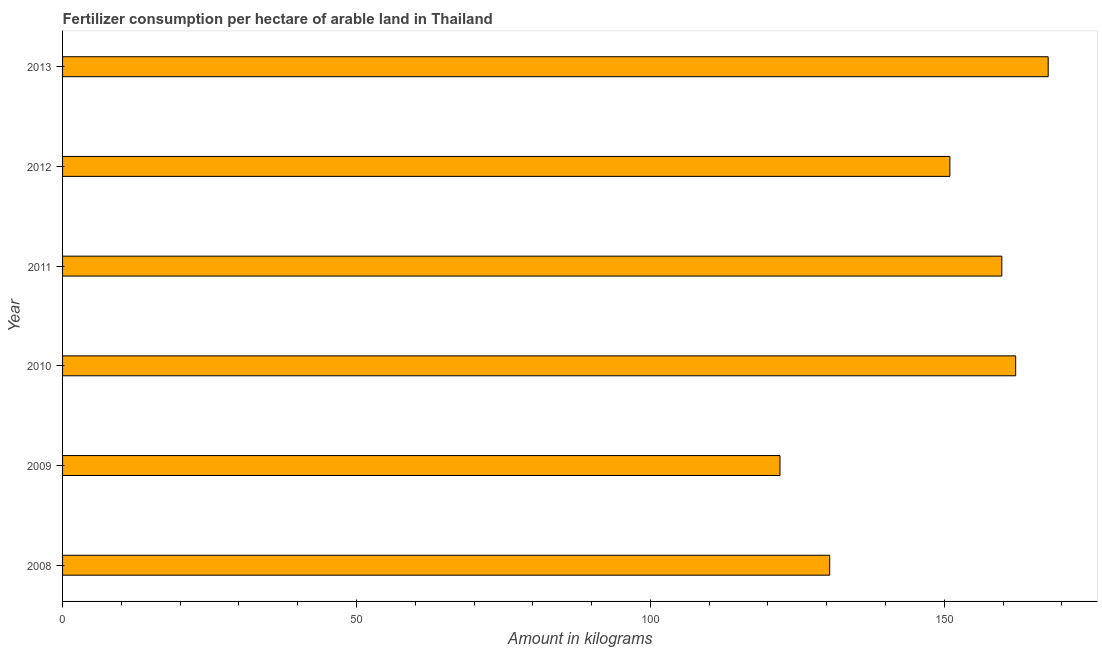Does the graph contain grids?
Provide a short and direct response. No. What is the title of the graph?
Provide a short and direct response. Fertilizer consumption per hectare of arable land in Thailand . What is the label or title of the X-axis?
Your answer should be very brief. Amount in kilograms. What is the amount of fertilizer consumption in 2011?
Give a very brief answer. 159.8. Across all years, what is the maximum amount of fertilizer consumption?
Ensure brevity in your answer.  167.69. Across all years, what is the minimum amount of fertilizer consumption?
Your answer should be very brief. 122.06. In which year was the amount of fertilizer consumption minimum?
Provide a short and direct response. 2009. What is the sum of the amount of fertilizer consumption?
Provide a short and direct response. 893.19. What is the difference between the amount of fertilizer consumption in 2009 and 2010?
Offer a very short reply. -40.1. What is the average amount of fertilizer consumption per year?
Provide a short and direct response. 148.86. What is the median amount of fertilizer consumption?
Ensure brevity in your answer.  155.38. In how many years, is the amount of fertilizer consumption greater than 80 kg?
Make the answer very short. 6. What is the ratio of the amount of fertilizer consumption in 2009 to that in 2010?
Offer a very short reply. 0.75. Is the difference between the amount of fertilizer consumption in 2011 and 2013 greater than the difference between any two years?
Offer a terse response. No. What is the difference between the highest and the second highest amount of fertilizer consumption?
Offer a very short reply. 5.54. Is the sum of the amount of fertilizer consumption in 2010 and 2011 greater than the maximum amount of fertilizer consumption across all years?
Offer a terse response. Yes. What is the difference between the highest and the lowest amount of fertilizer consumption?
Provide a succinct answer. 45.63. In how many years, is the amount of fertilizer consumption greater than the average amount of fertilizer consumption taken over all years?
Your response must be concise. 4. Are all the bars in the graph horizontal?
Provide a short and direct response. Yes. What is the difference between two consecutive major ticks on the X-axis?
Provide a succinct answer. 50. Are the values on the major ticks of X-axis written in scientific E-notation?
Your answer should be very brief. No. What is the Amount in kilograms in 2008?
Offer a very short reply. 130.52. What is the Amount in kilograms in 2009?
Your answer should be compact. 122.06. What is the Amount in kilograms in 2010?
Give a very brief answer. 162.16. What is the Amount in kilograms in 2011?
Your response must be concise. 159.8. What is the Amount in kilograms of 2012?
Your answer should be very brief. 150.96. What is the Amount in kilograms in 2013?
Keep it short and to the point. 167.69. What is the difference between the Amount in kilograms in 2008 and 2009?
Provide a succinct answer. 8.46. What is the difference between the Amount in kilograms in 2008 and 2010?
Your answer should be compact. -31.64. What is the difference between the Amount in kilograms in 2008 and 2011?
Keep it short and to the point. -29.28. What is the difference between the Amount in kilograms in 2008 and 2012?
Your response must be concise. -20.44. What is the difference between the Amount in kilograms in 2008 and 2013?
Provide a short and direct response. -37.17. What is the difference between the Amount in kilograms in 2009 and 2010?
Your answer should be compact. -40.1. What is the difference between the Amount in kilograms in 2009 and 2011?
Ensure brevity in your answer.  -37.74. What is the difference between the Amount in kilograms in 2009 and 2012?
Provide a succinct answer. -28.9. What is the difference between the Amount in kilograms in 2009 and 2013?
Provide a short and direct response. -45.63. What is the difference between the Amount in kilograms in 2010 and 2011?
Ensure brevity in your answer.  2.36. What is the difference between the Amount in kilograms in 2010 and 2012?
Offer a terse response. 11.19. What is the difference between the Amount in kilograms in 2010 and 2013?
Provide a short and direct response. -5.54. What is the difference between the Amount in kilograms in 2011 and 2012?
Give a very brief answer. 8.84. What is the difference between the Amount in kilograms in 2011 and 2013?
Keep it short and to the point. -7.89. What is the difference between the Amount in kilograms in 2012 and 2013?
Your answer should be compact. -16.73. What is the ratio of the Amount in kilograms in 2008 to that in 2009?
Offer a terse response. 1.07. What is the ratio of the Amount in kilograms in 2008 to that in 2010?
Make the answer very short. 0.81. What is the ratio of the Amount in kilograms in 2008 to that in 2011?
Offer a terse response. 0.82. What is the ratio of the Amount in kilograms in 2008 to that in 2012?
Provide a short and direct response. 0.86. What is the ratio of the Amount in kilograms in 2008 to that in 2013?
Provide a short and direct response. 0.78. What is the ratio of the Amount in kilograms in 2009 to that in 2010?
Make the answer very short. 0.75. What is the ratio of the Amount in kilograms in 2009 to that in 2011?
Provide a succinct answer. 0.76. What is the ratio of the Amount in kilograms in 2009 to that in 2012?
Ensure brevity in your answer.  0.81. What is the ratio of the Amount in kilograms in 2009 to that in 2013?
Ensure brevity in your answer.  0.73. What is the ratio of the Amount in kilograms in 2010 to that in 2012?
Your answer should be very brief. 1.07. What is the ratio of the Amount in kilograms in 2010 to that in 2013?
Ensure brevity in your answer.  0.97. What is the ratio of the Amount in kilograms in 2011 to that in 2012?
Your response must be concise. 1.06. What is the ratio of the Amount in kilograms in 2011 to that in 2013?
Provide a succinct answer. 0.95. What is the ratio of the Amount in kilograms in 2012 to that in 2013?
Your response must be concise. 0.9. 